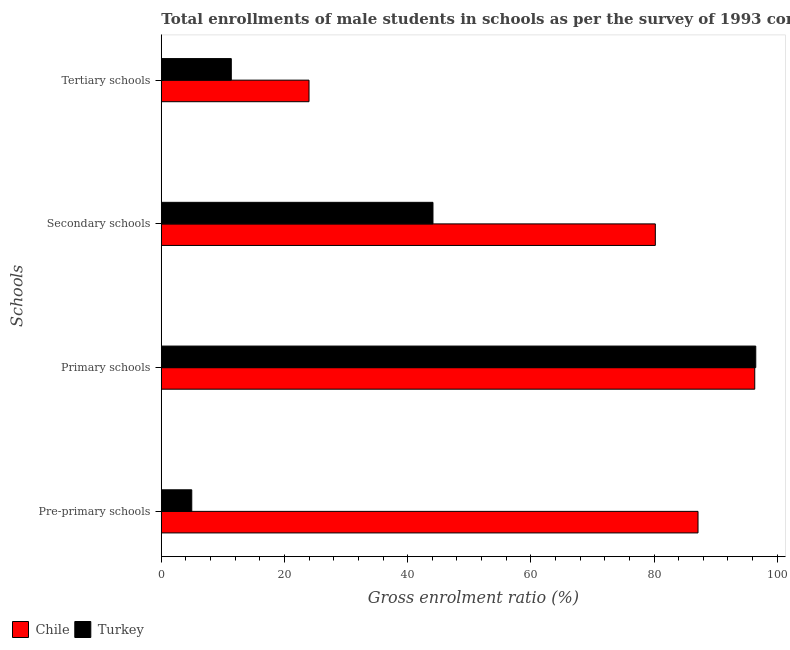How many different coloured bars are there?
Offer a terse response. 2. How many bars are there on the 1st tick from the top?
Give a very brief answer. 2. How many bars are there on the 2nd tick from the bottom?
Your response must be concise. 2. What is the label of the 1st group of bars from the top?
Ensure brevity in your answer.  Tertiary schools. What is the gross enrolment ratio(male) in secondary schools in Chile?
Ensure brevity in your answer.  80.21. Across all countries, what is the maximum gross enrolment ratio(male) in primary schools?
Your response must be concise. 96.52. Across all countries, what is the minimum gross enrolment ratio(male) in pre-primary schools?
Your response must be concise. 4.94. What is the total gross enrolment ratio(male) in primary schools in the graph?
Keep it short and to the point. 192.88. What is the difference between the gross enrolment ratio(male) in pre-primary schools in Chile and that in Turkey?
Offer a very short reply. 82.2. What is the difference between the gross enrolment ratio(male) in tertiary schools in Chile and the gross enrolment ratio(male) in primary schools in Turkey?
Your answer should be very brief. -72.54. What is the average gross enrolment ratio(male) in tertiary schools per country?
Your response must be concise. 17.67. What is the difference between the gross enrolment ratio(male) in primary schools and gross enrolment ratio(male) in secondary schools in Chile?
Ensure brevity in your answer.  16.15. In how many countries, is the gross enrolment ratio(male) in pre-primary schools greater than 44 %?
Your answer should be very brief. 1. What is the ratio of the gross enrolment ratio(male) in secondary schools in Turkey to that in Chile?
Provide a succinct answer. 0.55. What is the difference between the highest and the second highest gross enrolment ratio(male) in secondary schools?
Give a very brief answer. 36.1. What is the difference between the highest and the lowest gross enrolment ratio(male) in secondary schools?
Provide a short and direct response. 36.1. Is the sum of the gross enrolment ratio(male) in pre-primary schools in Turkey and Chile greater than the maximum gross enrolment ratio(male) in primary schools across all countries?
Keep it short and to the point. No. Is it the case that in every country, the sum of the gross enrolment ratio(male) in tertiary schools and gross enrolment ratio(male) in primary schools is greater than the sum of gross enrolment ratio(male) in secondary schools and gross enrolment ratio(male) in pre-primary schools?
Ensure brevity in your answer.  No. What does the 1st bar from the top in Tertiary schools represents?
Give a very brief answer. Turkey. How many bars are there?
Ensure brevity in your answer.  8. How many legend labels are there?
Your answer should be compact. 2. How are the legend labels stacked?
Your answer should be very brief. Horizontal. What is the title of the graph?
Offer a terse response. Total enrollments of male students in schools as per the survey of 1993 conducted in different countries. Does "Moldova" appear as one of the legend labels in the graph?
Ensure brevity in your answer.  No. What is the label or title of the Y-axis?
Ensure brevity in your answer.  Schools. What is the Gross enrolment ratio (%) of Chile in Pre-primary schools?
Give a very brief answer. 87.14. What is the Gross enrolment ratio (%) in Turkey in Pre-primary schools?
Your response must be concise. 4.94. What is the Gross enrolment ratio (%) of Chile in Primary schools?
Offer a terse response. 96.36. What is the Gross enrolment ratio (%) in Turkey in Primary schools?
Make the answer very short. 96.52. What is the Gross enrolment ratio (%) of Chile in Secondary schools?
Provide a short and direct response. 80.21. What is the Gross enrolment ratio (%) in Turkey in Secondary schools?
Provide a succinct answer. 44.11. What is the Gross enrolment ratio (%) in Chile in Tertiary schools?
Your answer should be compact. 23.98. What is the Gross enrolment ratio (%) in Turkey in Tertiary schools?
Provide a short and direct response. 11.36. Across all Schools, what is the maximum Gross enrolment ratio (%) of Chile?
Offer a very short reply. 96.36. Across all Schools, what is the maximum Gross enrolment ratio (%) in Turkey?
Your response must be concise. 96.52. Across all Schools, what is the minimum Gross enrolment ratio (%) of Chile?
Make the answer very short. 23.98. Across all Schools, what is the minimum Gross enrolment ratio (%) in Turkey?
Your response must be concise. 4.94. What is the total Gross enrolment ratio (%) in Chile in the graph?
Give a very brief answer. 287.7. What is the total Gross enrolment ratio (%) of Turkey in the graph?
Your answer should be very brief. 156.94. What is the difference between the Gross enrolment ratio (%) in Chile in Pre-primary schools and that in Primary schools?
Offer a very short reply. -9.21. What is the difference between the Gross enrolment ratio (%) of Turkey in Pre-primary schools and that in Primary schools?
Ensure brevity in your answer.  -91.58. What is the difference between the Gross enrolment ratio (%) in Chile in Pre-primary schools and that in Secondary schools?
Offer a very short reply. 6.93. What is the difference between the Gross enrolment ratio (%) of Turkey in Pre-primary schools and that in Secondary schools?
Your answer should be very brief. -39.16. What is the difference between the Gross enrolment ratio (%) of Chile in Pre-primary schools and that in Tertiary schools?
Give a very brief answer. 63.16. What is the difference between the Gross enrolment ratio (%) of Turkey in Pre-primary schools and that in Tertiary schools?
Provide a succinct answer. -6.42. What is the difference between the Gross enrolment ratio (%) in Chile in Primary schools and that in Secondary schools?
Your response must be concise. 16.15. What is the difference between the Gross enrolment ratio (%) in Turkey in Primary schools and that in Secondary schools?
Your answer should be very brief. 52.41. What is the difference between the Gross enrolment ratio (%) of Chile in Primary schools and that in Tertiary schools?
Your answer should be very brief. 72.37. What is the difference between the Gross enrolment ratio (%) of Turkey in Primary schools and that in Tertiary schools?
Keep it short and to the point. 85.16. What is the difference between the Gross enrolment ratio (%) of Chile in Secondary schools and that in Tertiary schools?
Ensure brevity in your answer.  56.23. What is the difference between the Gross enrolment ratio (%) of Turkey in Secondary schools and that in Tertiary schools?
Provide a short and direct response. 32.75. What is the difference between the Gross enrolment ratio (%) in Chile in Pre-primary schools and the Gross enrolment ratio (%) in Turkey in Primary schools?
Give a very brief answer. -9.38. What is the difference between the Gross enrolment ratio (%) of Chile in Pre-primary schools and the Gross enrolment ratio (%) of Turkey in Secondary schools?
Offer a terse response. 43.04. What is the difference between the Gross enrolment ratio (%) of Chile in Pre-primary schools and the Gross enrolment ratio (%) of Turkey in Tertiary schools?
Your response must be concise. 75.78. What is the difference between the Gross enrolment ratio (%) of Chile in Primary schools and the Gross enrolment ratio (%) of Turkey in Secondary schools?
Offer a very short reply. 52.25. What is the difference between the Gross enrolment ratio (%) of Chile in Primary schools and the Gross enrolment ratio (%) of Turkey in Tertiary schools?
Provide a succinct answer. 84.99. What is the difference between the Gross enrolment ratio (%) of Chile in Secondary schools and the Gross enrolment ratio (%) of Turkey in Tertiary schools?
Your answer should be very brief. 68.85. What is the average Gross enrolment ratio (%) of Chile per Schools?
Your response must be concise. 71.92. What is the average Gross enrolment ratio (%) in Turkey per Schools?
Offer a very short reply. 39.23. What is the difference between the Gross enrolment ratio (%) of Chile and Gross enrolment ratio (%) of Turkey in Pre-primary schools?
Your answer should be very brief. 82.2. What is the difference between the Gross enrolment ratio (%) of Chile and Gross enrolment ratio (%) of Turkey in Primary schools?
Your response must be concise. -0.16. What is the difference between the Gross enrolment ratio (%) in Chile and Gross enrolment ratio (%) in Turkey in Secondary schools?
Provide a short and direct response. 36.1. What is the difference between the Gross enrolment ratio (%) in Chile and Gross enrolment ratio (%) in Turkey in Tertiary schools?
Give a very brief answer. 12.62. What is the ratio of the Gross enrolment ratio (%) of Chile in Pre-primary schools to that in Primary schools?
Make the answer very short. 0.9. What is the ratio of the Gross enrolment ratio (%) of Turkey in Pre-primary schools to that in Primary schools?
Offer a terse response. 0.05. What is the ratio of the Gross enrolment ratio (%) in Chile in Pre-primary schools to that in Secondary schools?
Offer a very short reply. 1.09. What is the ratio of the Gross enrolment ratio (%) of Turkey in Pre-primary schools to that in Secondary schools?
Give a very brief answer. 0.11. What is the ratio of the Gross enrolment ratio (%) in Chile in Pre-primary schools to that in Tertiary schools?
Provide a succinct answer. 3.63. What is the ratio of the Gross enrolment ratio (%) of Turkey in Pre-primary schools to that in Tertiary schools?
Provide a short and direct response. 0.44. What is the ratio of the Gross enrolment ratio (%) of Chile in Primary schools to that in Secondary schools?
Your answer should be very brief. 1.2. What is the ratio of the Gross enrolment ratio (%) of Turkey in Primary schools to that in Secondary schools?
Provide a short and direct response. 2.19. What is the ratio of the Gross enrolment ratio (%) in Chile in Primary schools to that in Tertiary schools?
Provide a succinct answer. 4.02. What is the ratio of the Gross enrolment ratio (%) of Turkey in Primary schools to that in Tertiary schools?
Give a very brief answer. 8.49. What is the ratio of the Gross enrolment ratio (%) in Chile in Secondary schools to that in Tertiary schools?
Provide a succinct answer. 3.34. What is the ratio of the Gross enrolment ratio (%) in Turkey in Secondary schools to that in Tertiary schools?
Your response must be concise. 3.88. What is the difference between the highest and the second highest Gross enrolment ratio (%) of Chile?
Provide a short and direct response. 9.21. What is the difference between the highest and the second highest Gross enrolment ratio (%) in Turkey?
Offer a very short reply. 52.41. What is the difference between the highest and the lowest Gross enrolment ratio (%) in Chile?
Provide a succinct answer. 72.37. What is the difference between the highest and the lowest Gross enrolment ratio (%) in Turkey?
Ensure brevity in your answer.  91.58. 